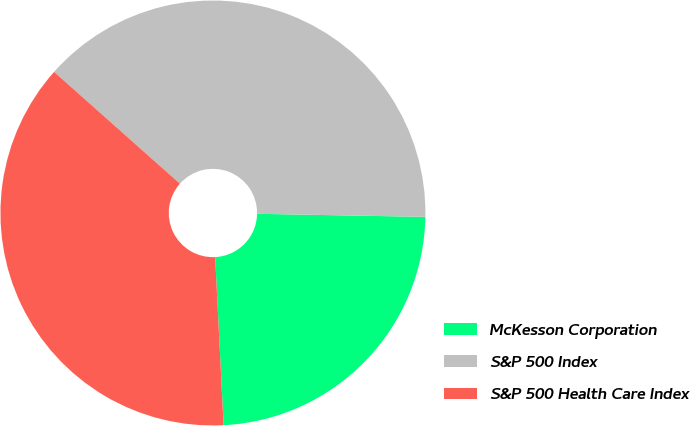Convert chart. <chart><loc_0><loc_0><loc_500><loc_500><pie_chart><fcel>McKesson Corporation<fcel>S&P 500 Index<fcel>S&P 500 Health Care Index<nl><fcel>23.91%<fcel>38.73%<fcel>37.36%<nl></chart> 